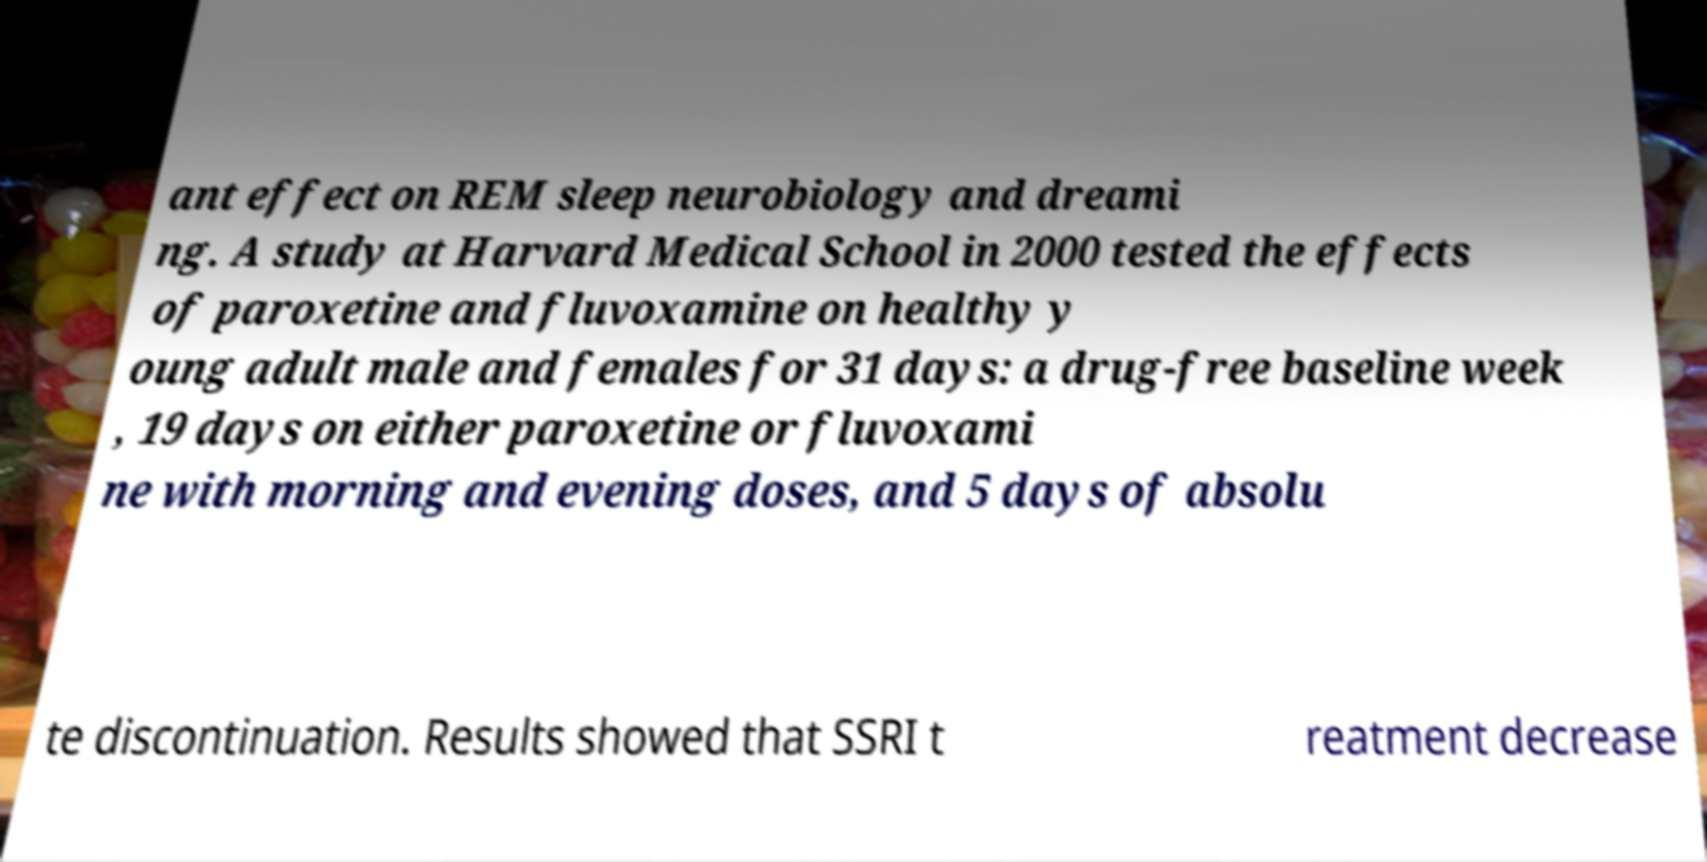For documentation purposes, I need the text within this image transcribed. Could you provide that? ant effect on REM sleep neurobiology and dreami ng. A study at Harvard Medical School in 2000 tested the effects of paroxetine and fluvoxamine on healthy y oung adult male and females for 31 days: a drug-free baseline week , 19 days on either paroxetine or fluvoxami ne with morning and evening doses, and 5 days of absolu te discontinuation. Results showed that SSRI t reatment decrease 